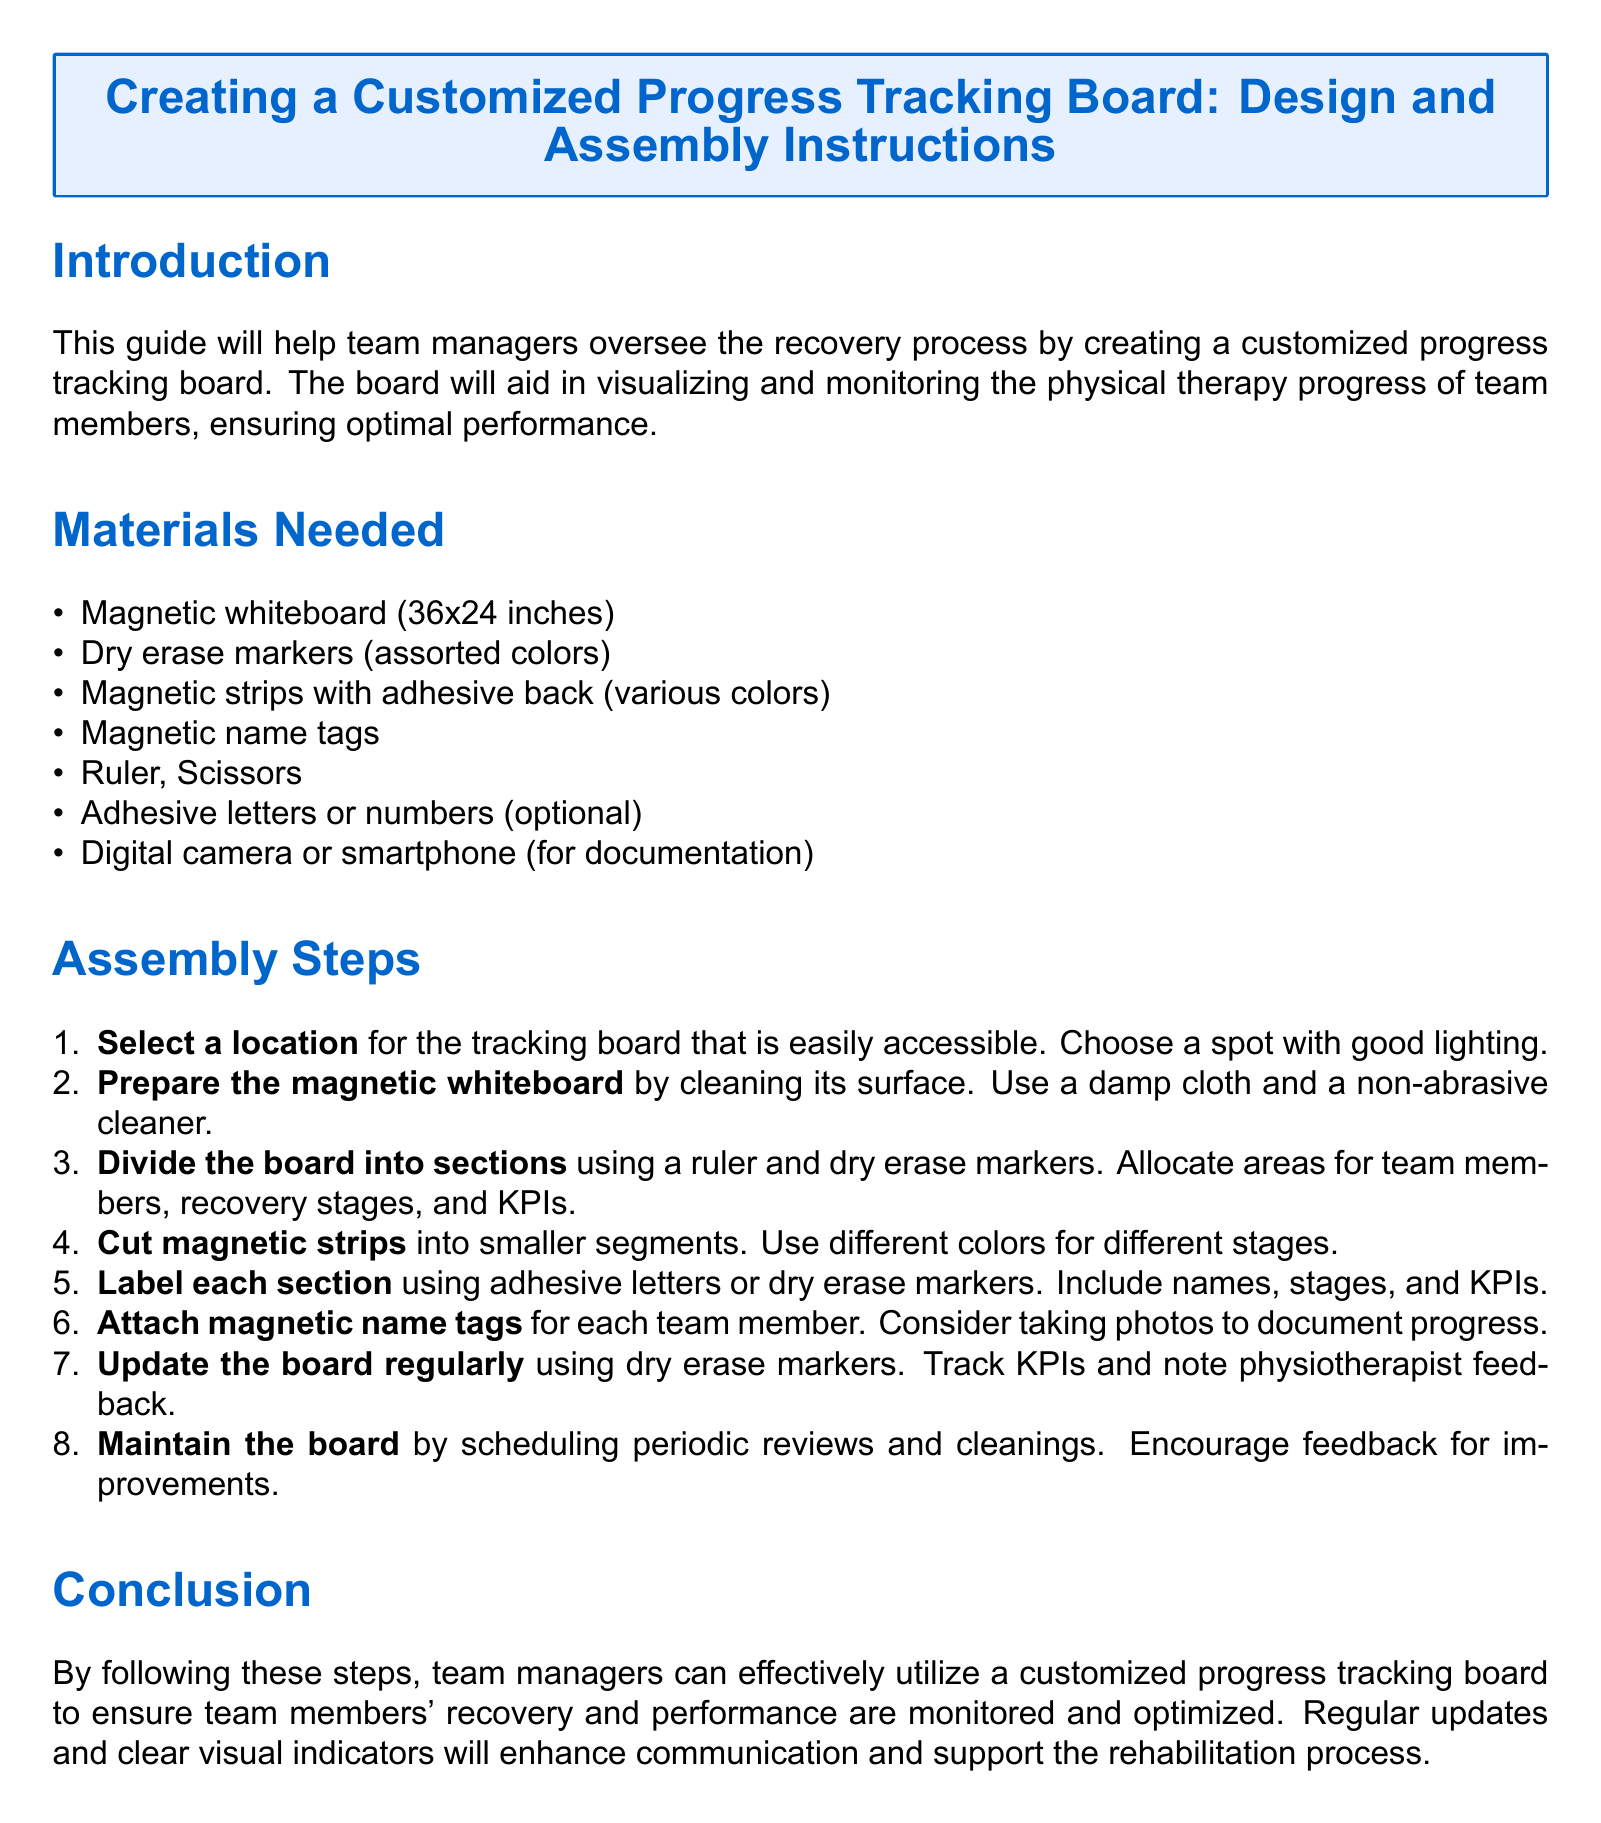What is the size of the magnetic whiteboard? The size of the magnetic whiteboard is stated in the materials section of the document as 36x24 inches.
Answer: 36x24 inches How many types of markers are mentioned? The document mentions "dry erase markers (assorted colors)" indicating there are multiple types.
Answer: Assorted colors What is used to divide the board into sections? The instructions specify using a ruler and dry erase markers to divide the board.
Answer: Ruler and dry erase markers What should be done to maintain the board? The document states that regular reviews and cleanings should be scheduled to maintain the board.
Answer: Periodic reviews and cleanings What color is the title of the document? The title color is defined in the document as RGB (0,102,204).
Answer: RGB (0,102,204) What should be done with the magnetic name tags? The document mentions attaching magnetic name tags for each team member.
Answer: Attach for each team member Which document section details the necessary materials? The "Materials Needed" section provides the details about the necessary materials for assembly.
Answer: Materials Needed How often should the board be updated? The assembly steps indicate that the board should be updated regularly.
Answer: Regularly 